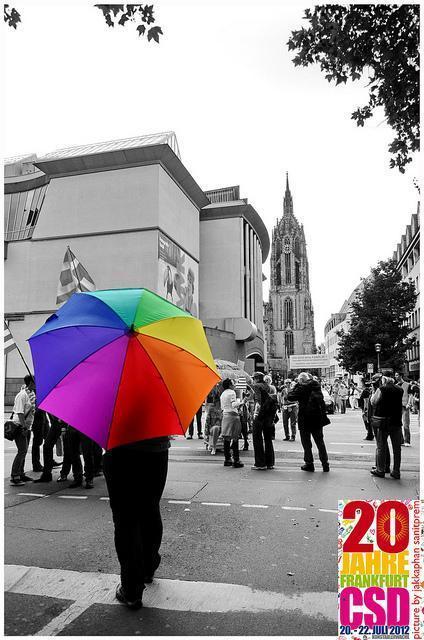How many people are there?
Give a very brief answer. 4. How many umbrellas are there?
Give a very brief answer. 1. How many prongs does the fork have?
Give a very brief answer. 0. 